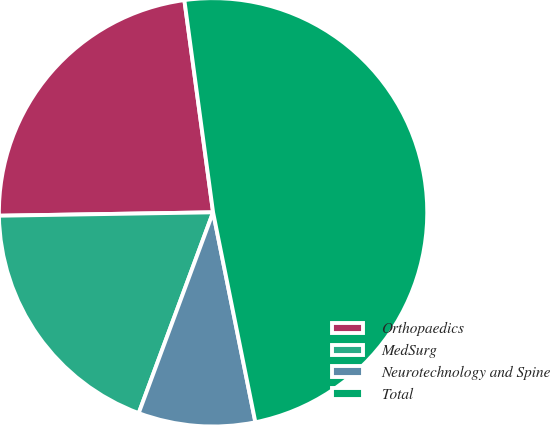Convert chart. <chart><loc_0><loc_0><loc_500><loc_500><pie_chart><fcel>Orthopaedics<fcel>MedSurg<fcel>Neurotechnology and Spine<fcel>Total<nl><fcel>23.11%<fcel>19.1%<fcel>8.81%<fcel>48.97%<nl></chart> 